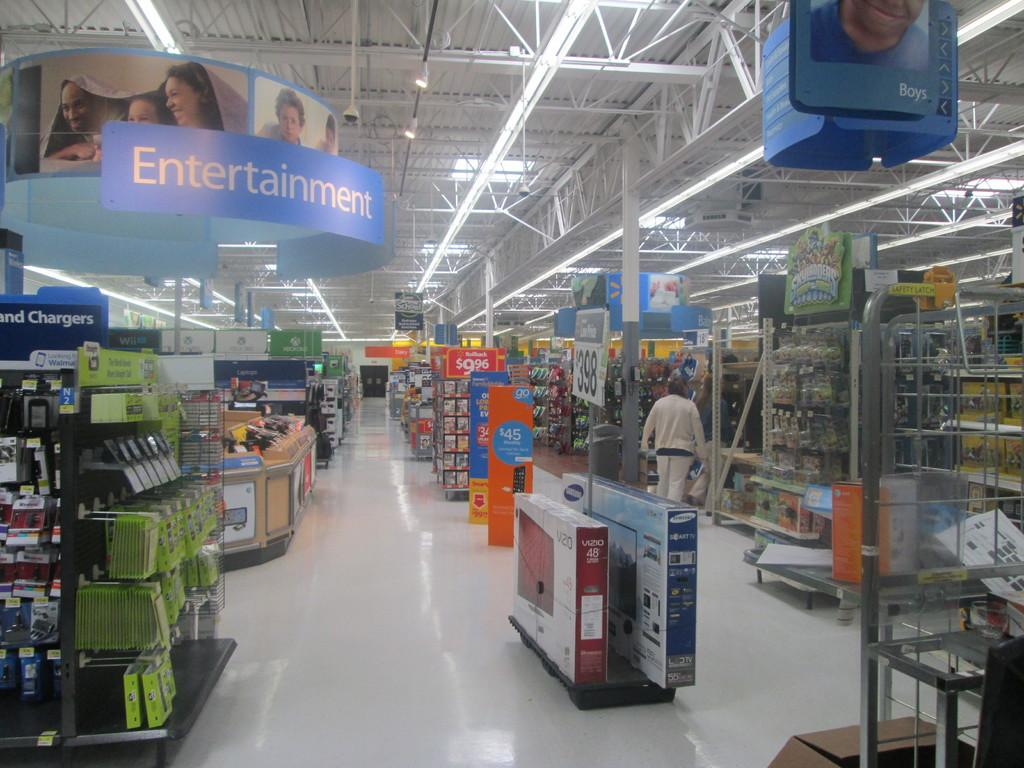<image>
Provide a brief description of the given image. A large sign hangs above the Entertainment section 